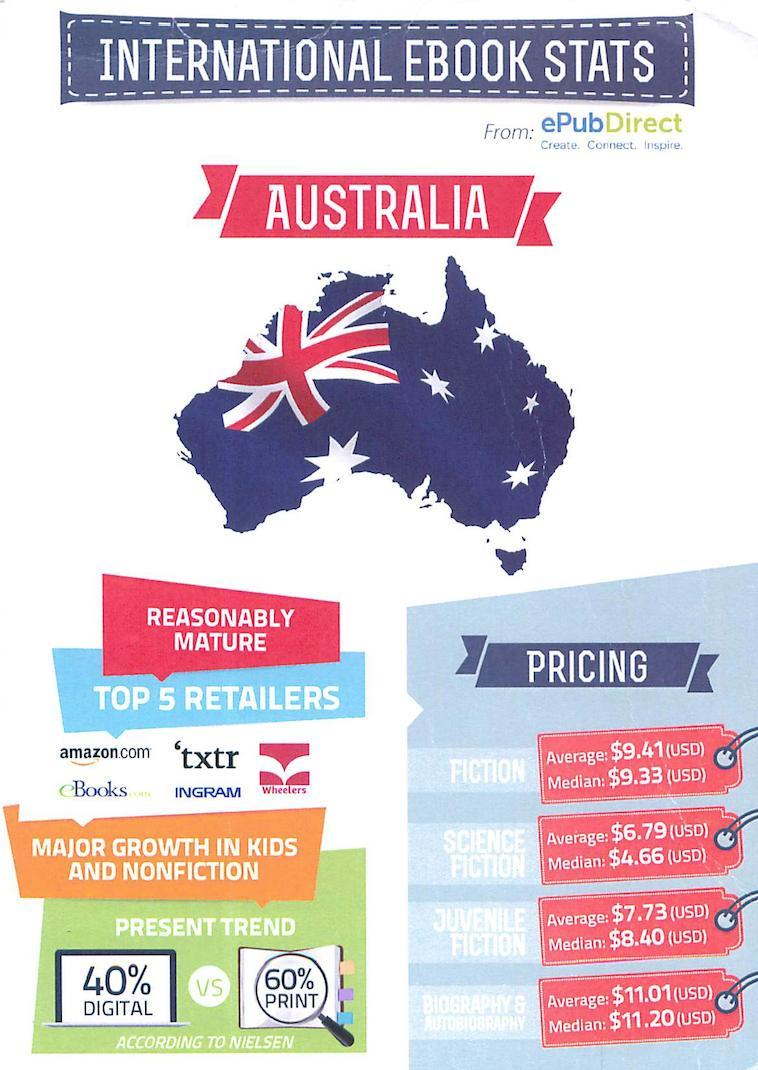what has the lowest pricing
Answer the question with a short phrase. science fiction who are wheelers top 5 retailers What is the difference in percentage between digital and print 20 what is the difference between average cost of juvenile fiction and science fiction .94 